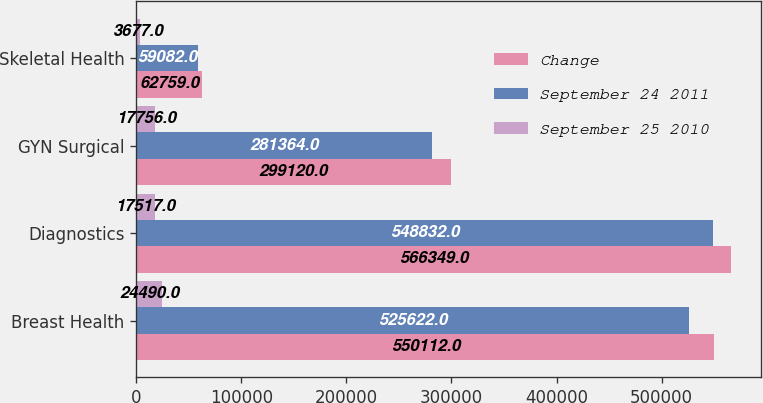Convert chart to OTSL. <chart><loc_0><loc_0><loc_500><loc_500><stacked_bar_chart><ecel><fcel>Breast Health<fcel>Diagnostics<fcel>GYN Surgical<fcel>Skeletal Health<nl><fcel>Change<fcel>550112<fcel>566349<fcel>299120<fcel>62759<nl><fcel>September 24 2011<fcel>525622<fcel>548832<fcel>281364<fcel>59082<nl><fcel>September 25 2010<fcel>24490<fcel>17517<fcel>17756<fcel>3677<nl></chart> 